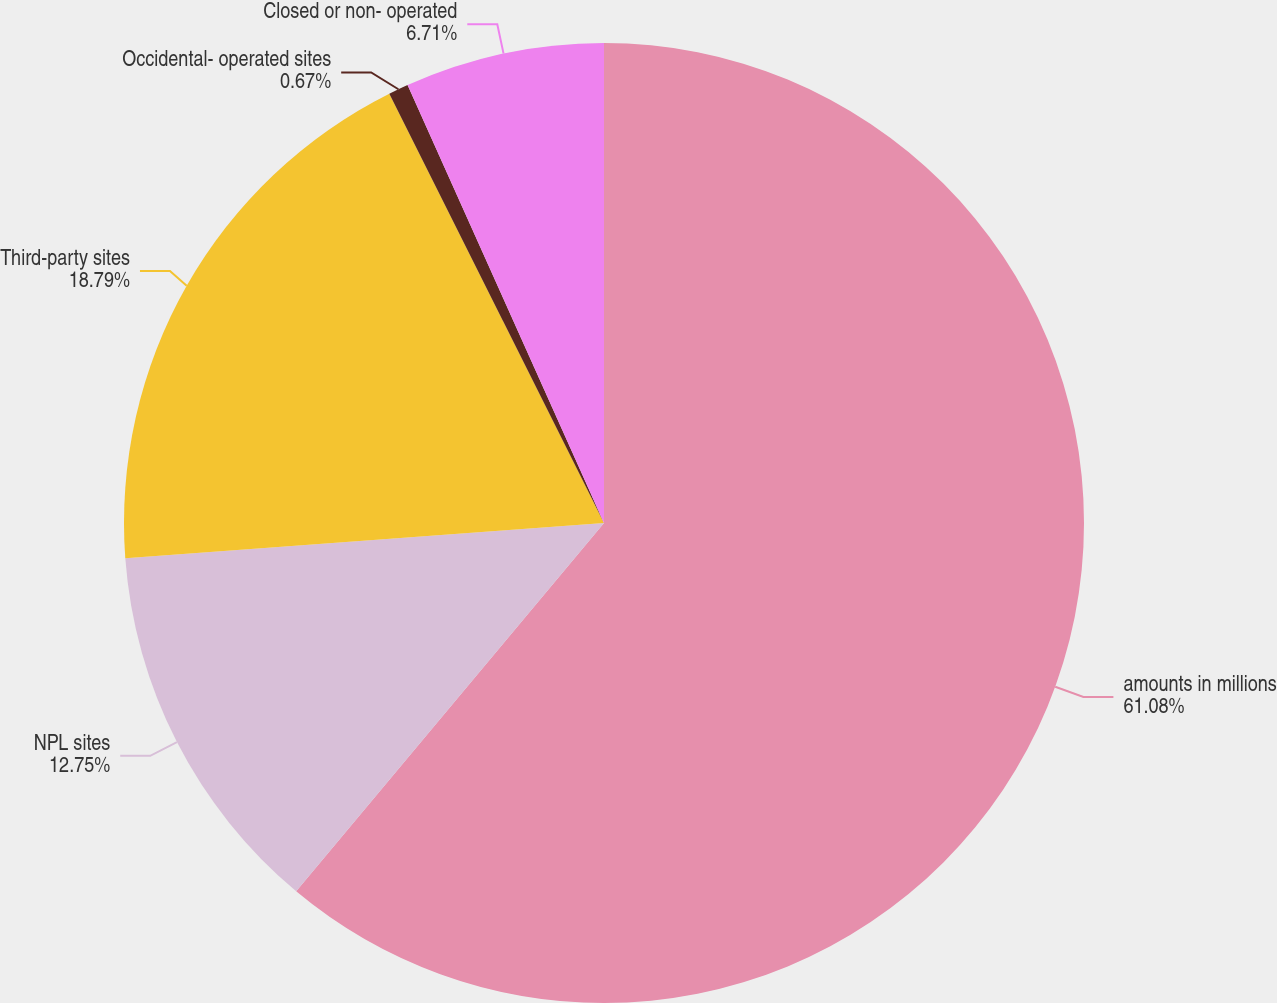Convert chart to OTSL. <chart><loc_0><loc_0><loc_500><loc_500><pie_chart><fcel>amounts in millions<fcel>NPL sites<fcel>Third-party sites<fcel>Occidental- operated sites<fcel>Closed or non- operated<nl><fcel>61.08%<fcel>12.75%<fcel>18.79%<fcel>0.67%<fcel>6.71%<nl></chart> 